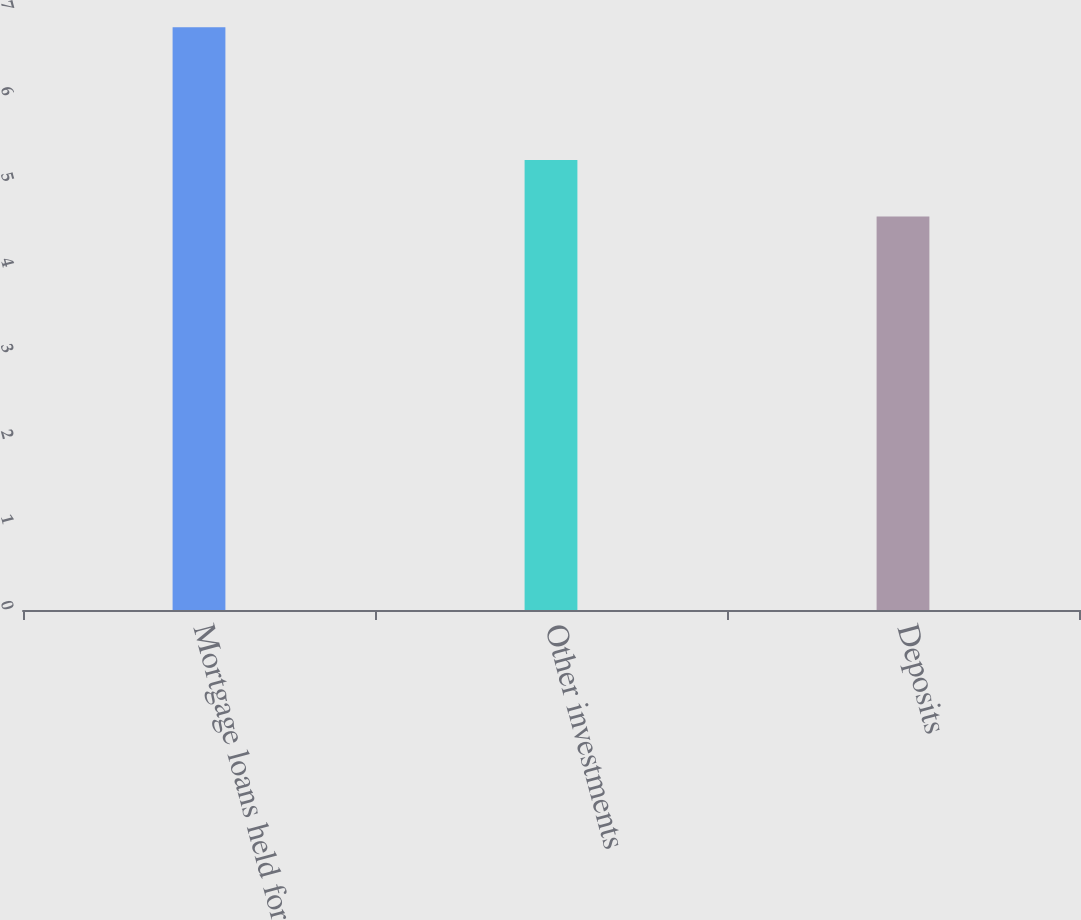Convert chart to OTSL. <chart><loc_0><loc_0><loc_500><loc_500><bar_chart><fcel>Mortgage loans held for<fcel>Other investments<fcel>Deposits<nl><fcel>6.8<fcel>5.25<fcel>4.59<nl></chart> 